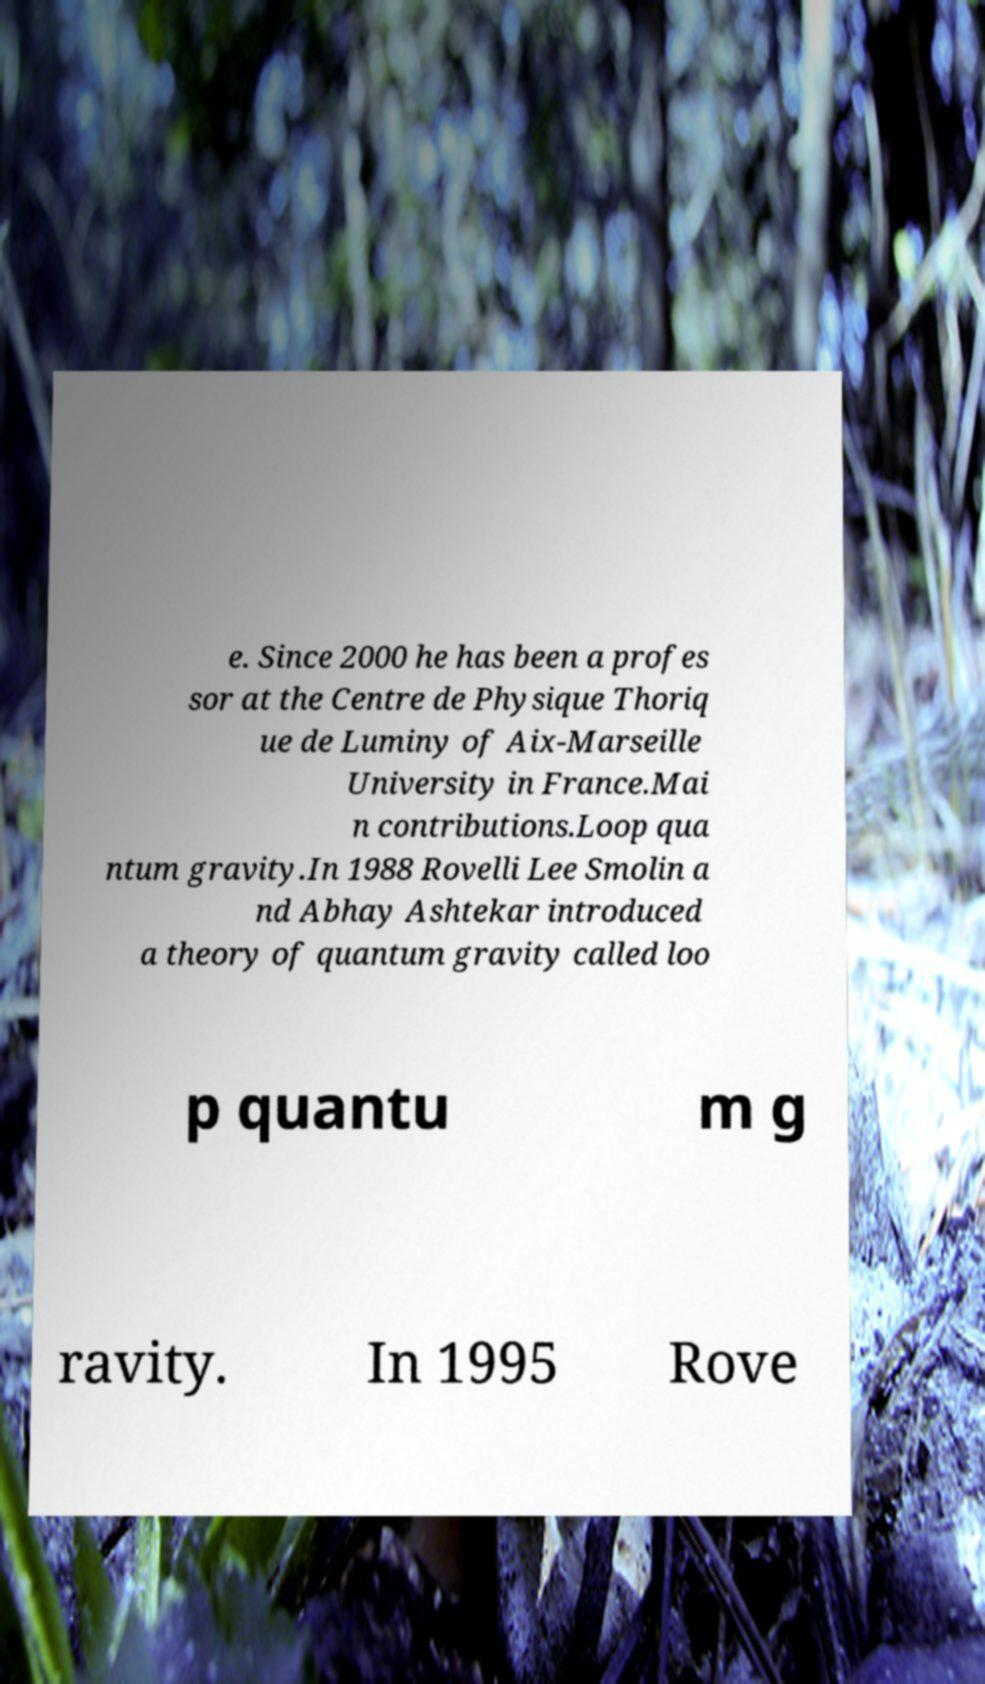For documentation purposes, I need the text within this image transcribed. Could you provide that? e. Since 2000 he has been a profes sor at the Centre de Physique Thoriq ue de Luminy of Aix-Marseille University in France.Mai n contributions.Loop qua ntum gravity.In 1988 Rovelli Lee Smolin a nd Abhay Ashtekar introduced a theory of quantum gravity called loo p quantu m g ravity. In 1995 Rove 